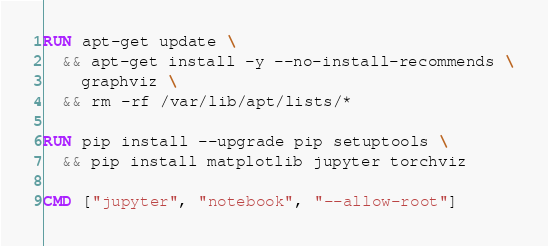Convert code to text. <code><loc_0><loc_0><loc_500><loc_500><_Dockerfile_>RUN apt-get update \
  && apt-get install -y --no-install-recommends \
    graphviz \
  && rm -rf /var/lib/apt/lists/*

RUN pip install --upgrade pip setuptools \
  && pip install matplotlib jupyter torchviz

CMD ["jupyter", "notebook", "--allow-root"]
</code> 